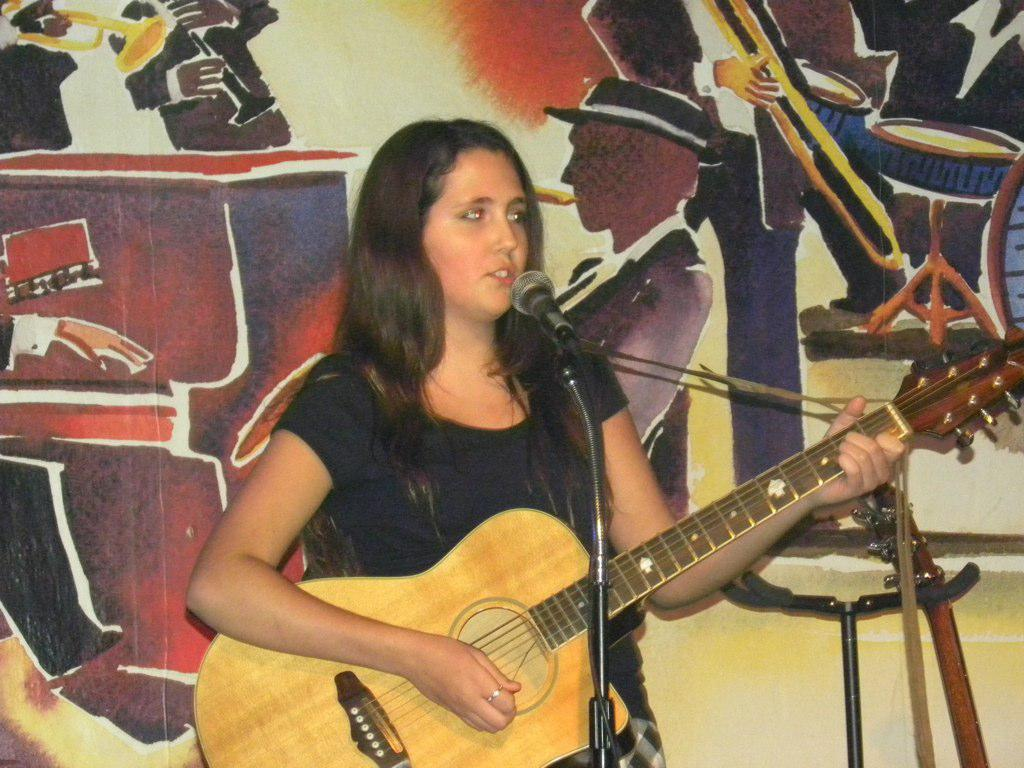Who is the main subject in the image? There is a woman in the image. What is the woman doing in the image? The woman is highlighted, and she is holding a guitar. What object is in front of the woman? There is a microphone with a mic holder in front of the woman. What can be seen on the wall in the background? The wall in the background is colorful. What type of tub is visible in the image? There is no tub present in the image. Can you tell me how many hammers the woman is holding in the image? The woman is not holding any hammers in the image; she is holding a guitar. 